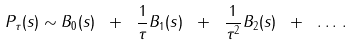<formula> <loc_0><loc_0><loc_500><loc_500>P _ { \tau } ( s ) \sim B _ { 0 } ( s ) \ + \ \frac { 1 } { \tau } B _ { 1 } ( s ) \ + \ \frac { 1 } { \tau ^ { 2 } } B _ { 2 } ( s ) \ + \ \dots \, .</formula> 